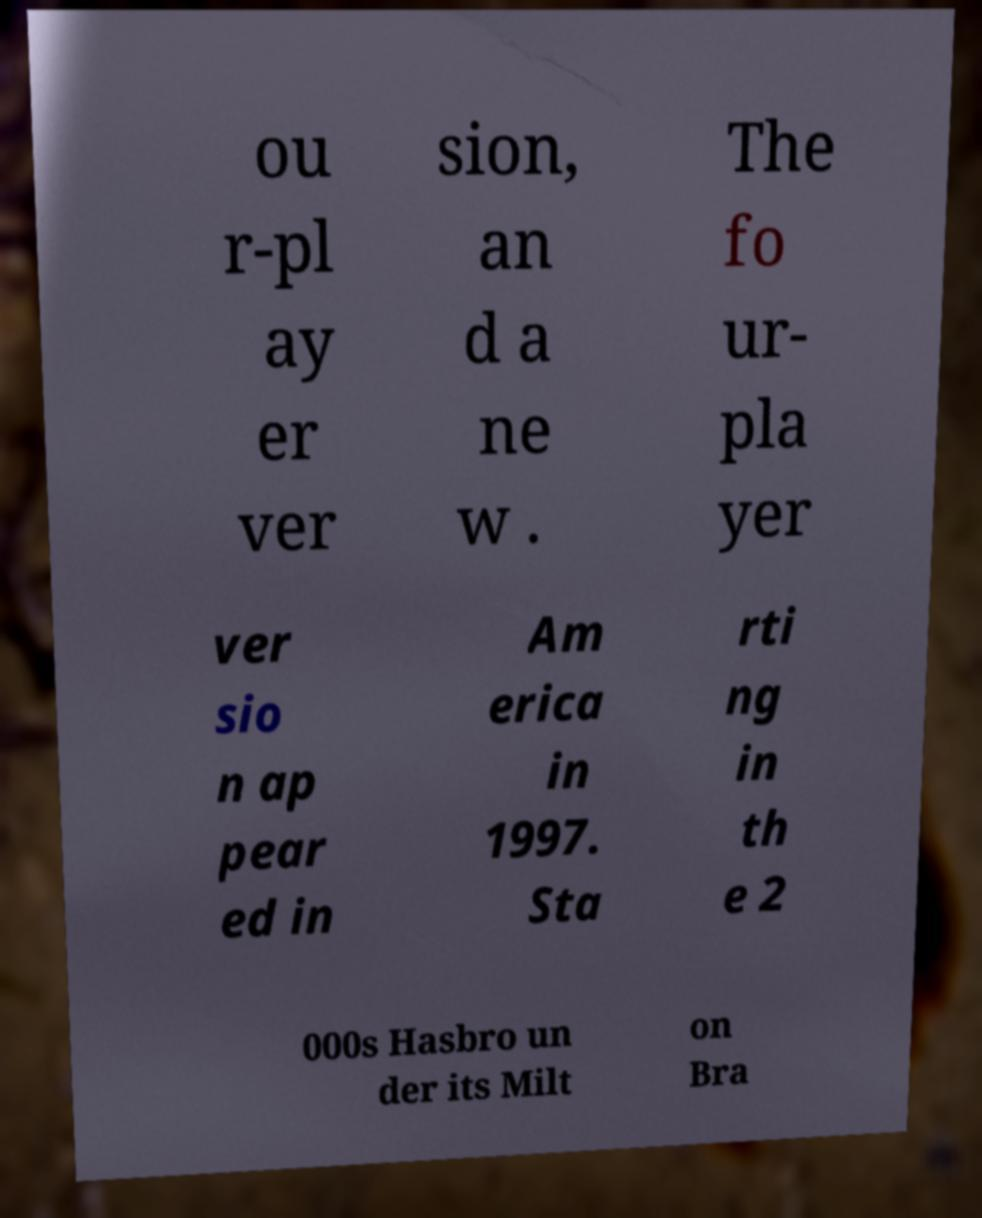For documentation purposes, I need the text within this image transcribed. Could you provide that? ou r-pl ay er ver sion, an d a ne w . The fo ur- pla yer ver sio n ap pear ed in Am erica in 1997. Sta rti ng in th e 2 000s Hasbro un der its Milt on Bra 